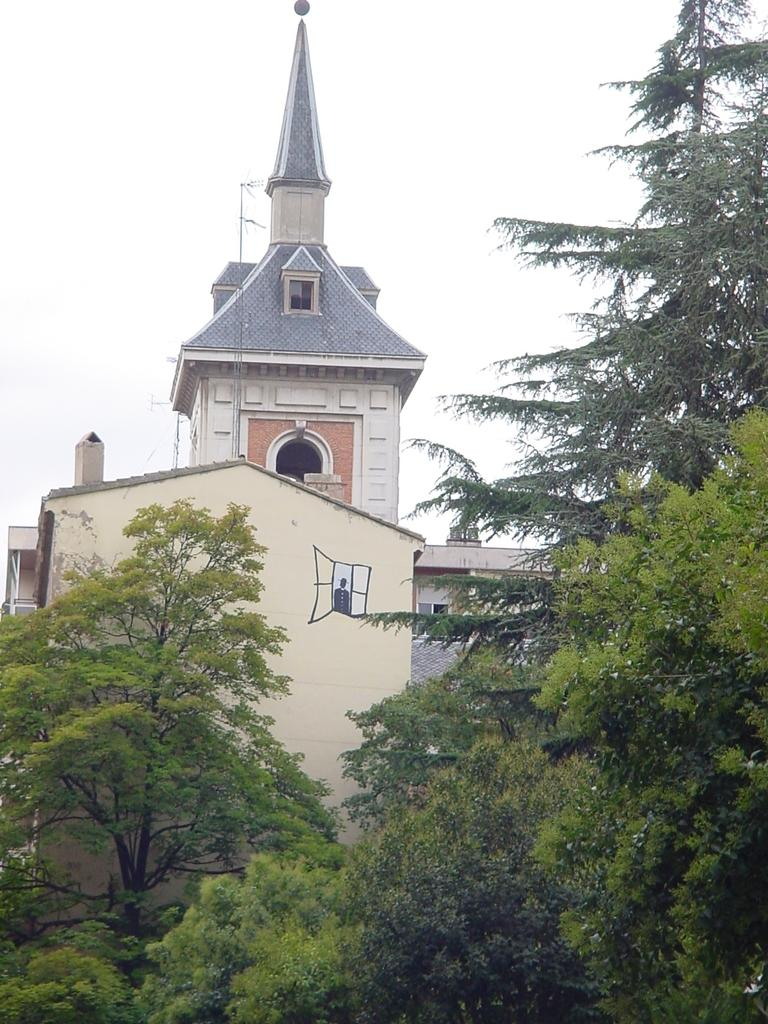What is located in the foreground of the picture? There are trees in the foreground of the foreground of the picture. What is the main structure in the center of the picture? There is a cathedral in the center of the picture. How would you describe the sky in the picture? The sky is cloudy in the picture. What type of vacation is the cathedral offering in the image? The image does not depict a vacation or any information about the cathedral offering a vacation. How many fingers can be seen pointing at the cathedral in the image? There are no fingers visible in the image, let alone pointing at the cathedral. 